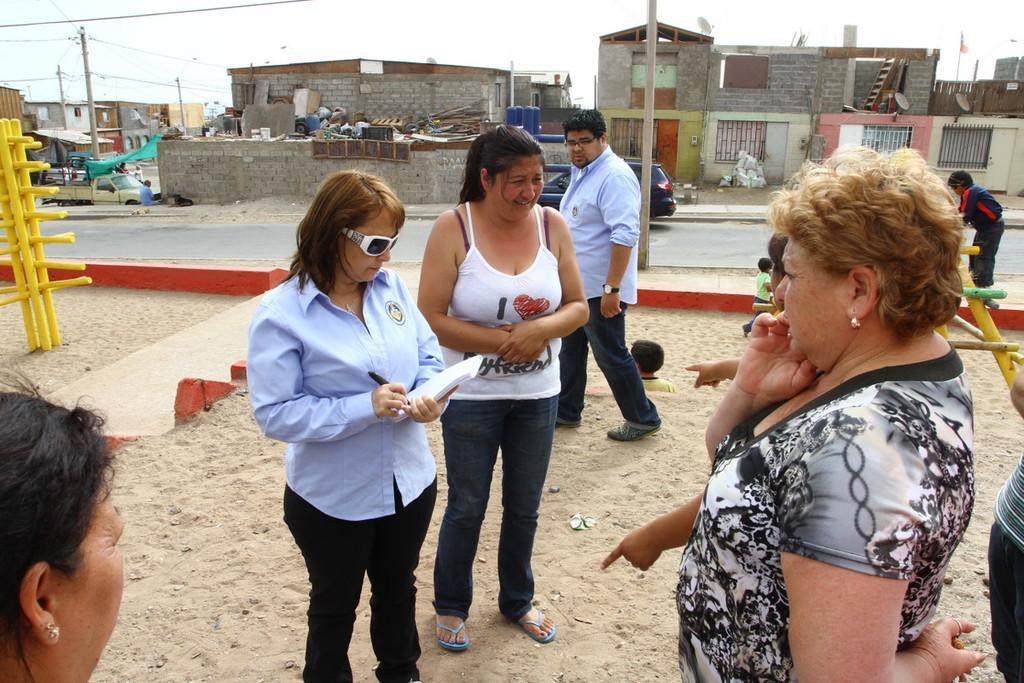Can you describe this image briefly? In this image there are persons standing in the center. There is a woman standing and holding a book and writing something on the book. In the background there are buildings, there is a car moving on the road and there are poles. On the left side there is a pole which is yellow in colour. 